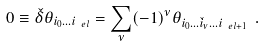<formula> <loc_0><loc_0><loc_500><loc_500>0 \equiv \check { \delta } \theta _ { i _ { 0 } \dots i _ { \ e l } } = \sum _ { \nu } ( - 1 ) ^ { \nu } \theta _ { i _ { 0 } \dots \check { i } _ { \nu } \dots i _ { \ e l + 1 } } \ .</formula> 